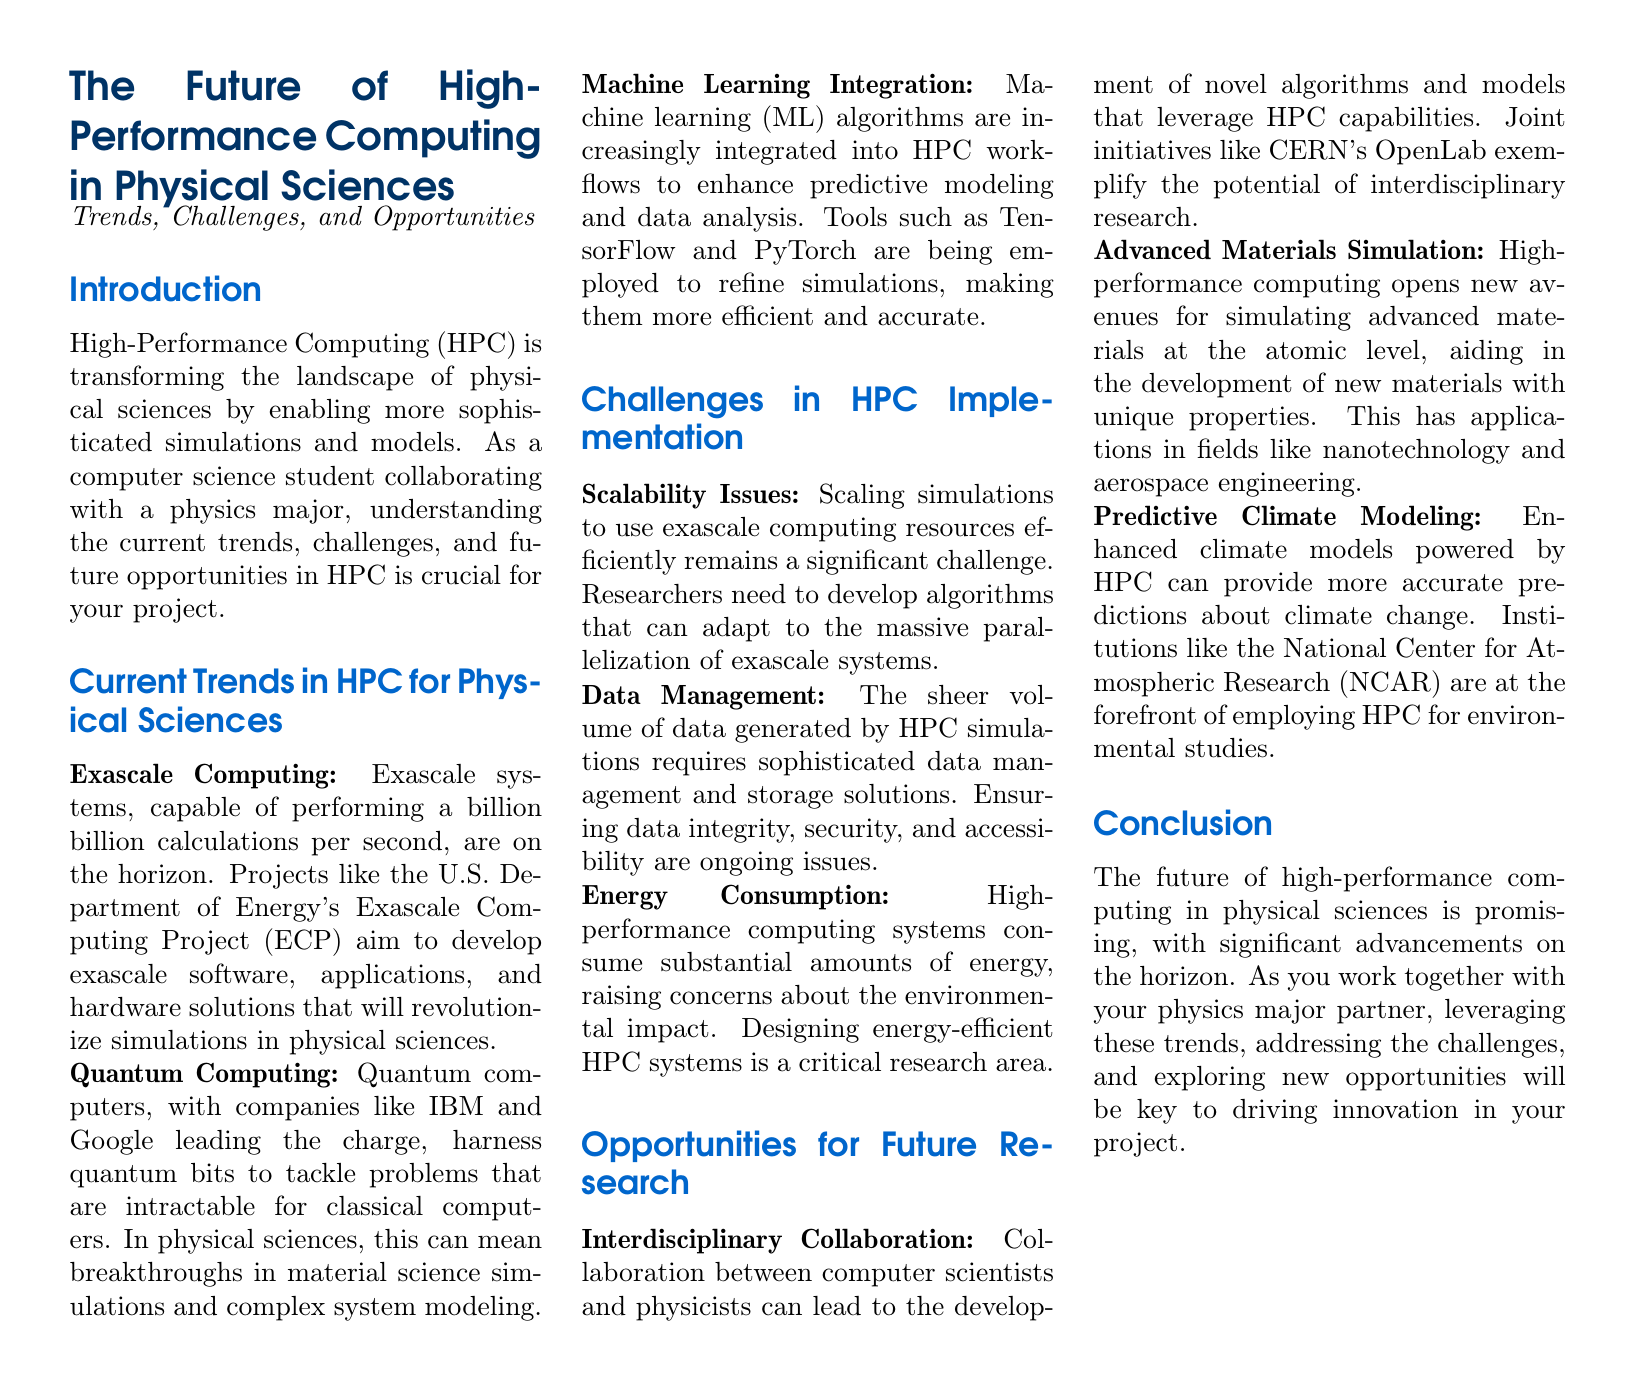What is the title of the document? The title is presented prominently at the top of the document, introducing the main topic covered which is the future of HPC in physical sciences.
Answer: The Future of High-Performance Computing in Physical Sciences What does HPC stand for? HPC is an acronym introduced in the document that stands for high-performance computing, which is pivotal in physical sciences research.
Answer: High-Performance Computing What is the projected capability of exascale systems? The document mentions that exascale systems are capable of performing a billion billion calculations per second, detailing their processing power.
Answer: A billion billion calculations per second Which organization is leading the Exascale Computing Project? The document identifies the U.S. Department of Energy as the organization behind the initiative aimed at developing exascale systems.
Answer: U.S. Department of Energy What integration is mentioned as enhancing predictive modeling? The document specifically states that machine learning (ML) algorithms are increasingly being integrated into HPC workflows for better modeling and data analysis.
Answer: Machine Learning What is a significant challenge related to HPC mentioned in the document? The document outlines multiple challenges; one of them is scalability issues when dealing with vast computations.
Answer: Scalability Issues Which initiative exemplifies interdisciplinary collaboration in HPC? The document gives an example of collaboration through CERN's OpenLab, which showcases how different disciplines can come together in HPC research.
Answer: CERN's OpenLab What aspect of climate modeling is highlighted in the opportunities section? The document emphasizes that enhanced climate models powered by HPC can yield more accurate predictions regarding climate change impacts.
Answer: Predictive Climate Modeling 